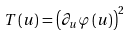<formula> <loc_0><loc_0><loc_500><loc_500>T \left ( u \right ) = \left ( \partial _ { u } \varphi \left ( u \right ) \right ) ^ { 2 }</formula> 